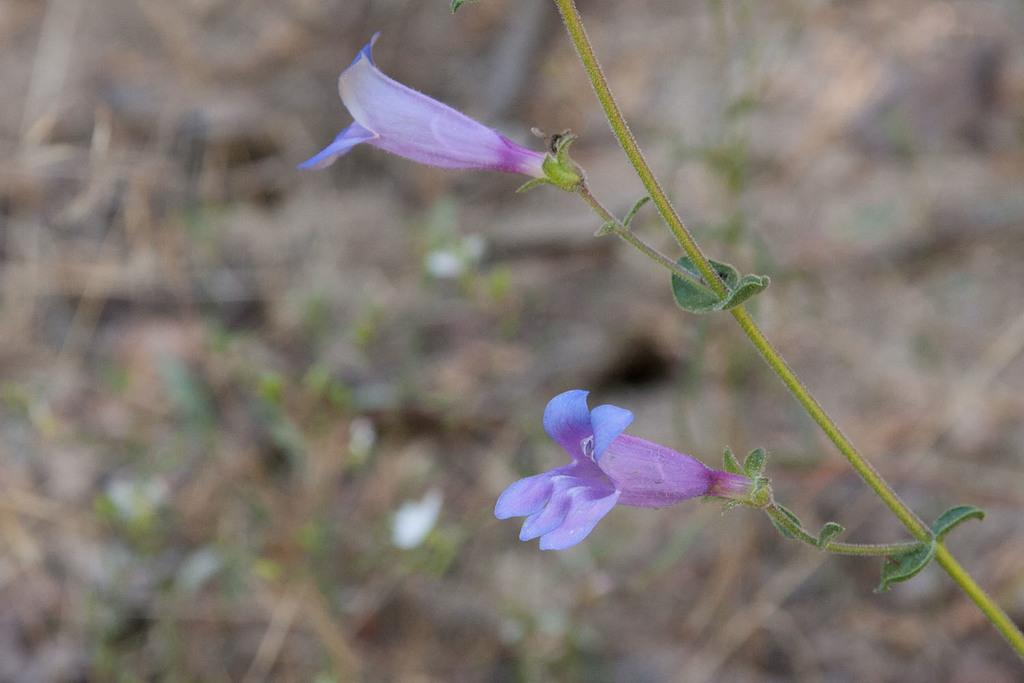How many flowers are present in the image? There are two flowers in the image. What colors are the flowers? One flower is pink in color, and the other flower is violet in color. What type of kettle is placed next to the flowers in the image? There is no kettle present in the image; it only features two flowers, one pink and one violet. 